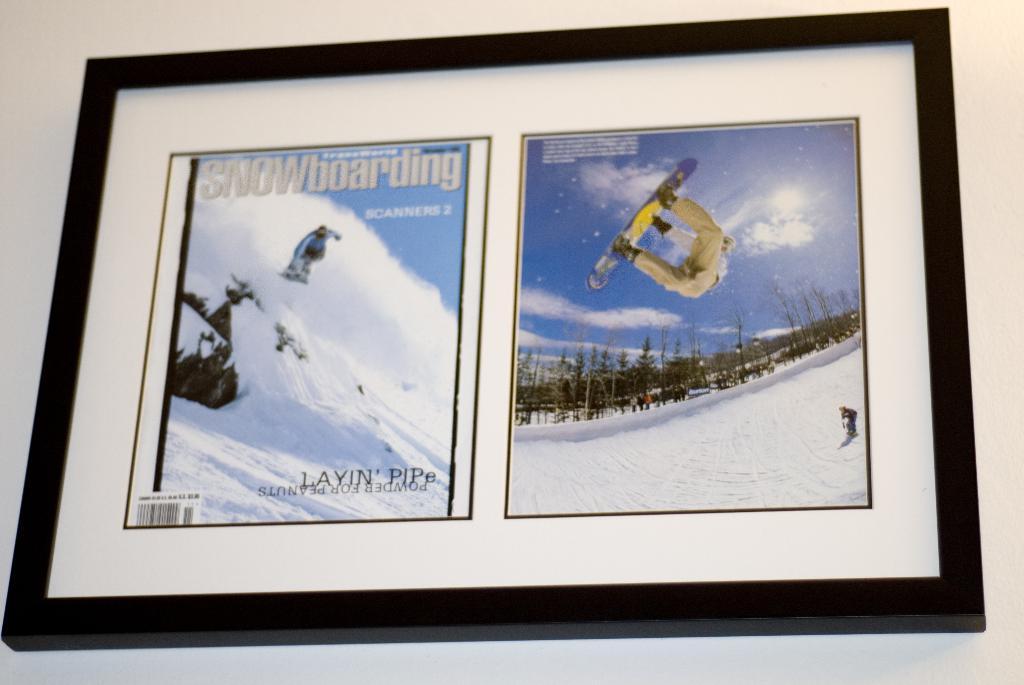What is this magazine about?
Make the answer very short. Snowboarding. What is the title of the main article in this magazine?
Provide a succinct answer. Snowboarding. 